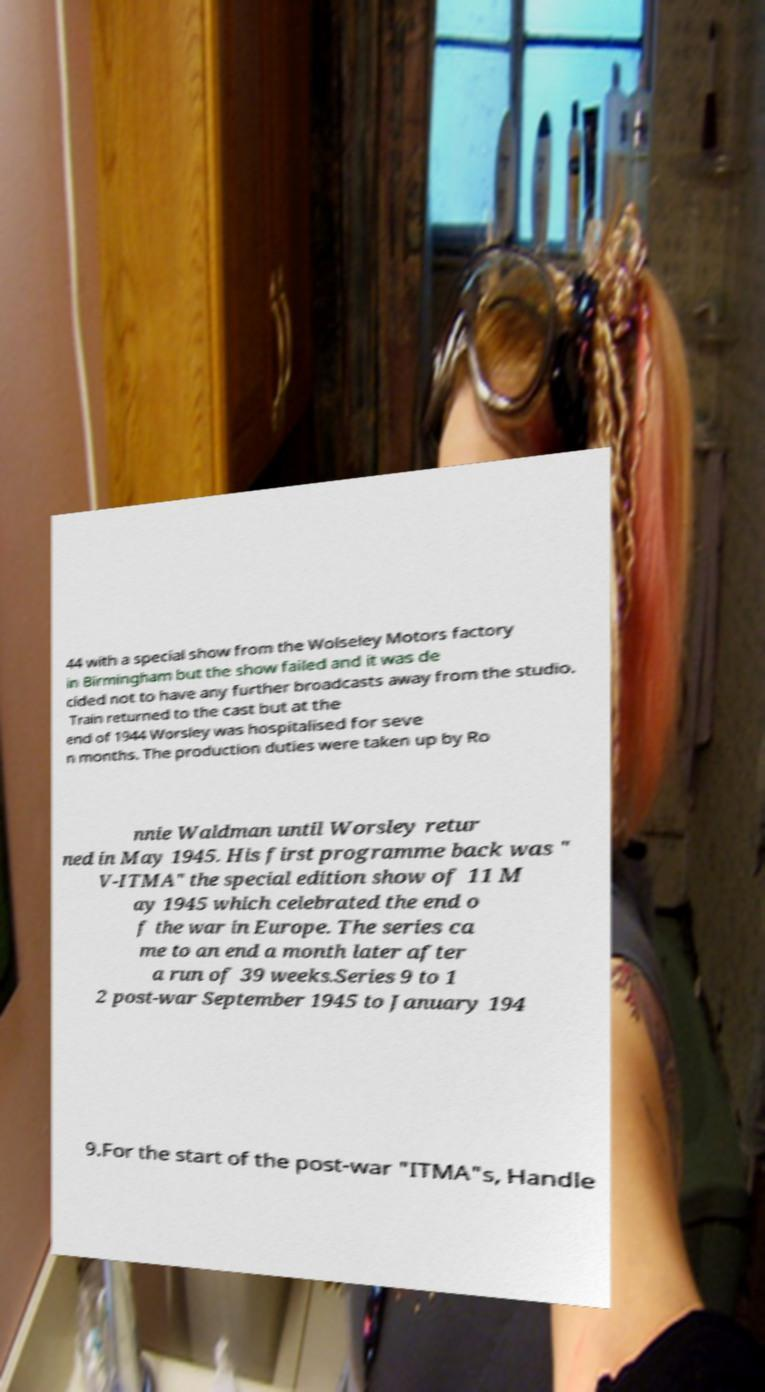Could you extract and type out the text from this image? 44 with a special show from the Wolseley Motors factory in Birmingham but the show failed and it was de cided not to have any further broadcasts away from the studio. Train returned to the cast but at the end of 1944 Worsley was hospitalised for seve n months. The production duties were taken up by Ro nnie Waldman until Worsley retur ned in May 1945. His first programme back was " V-ITMA" the special edition show of 11 M ay 1945 which celebrated the end o f the war in Europe. The series ca me to an end a month later after a run of 39 weeks.Series 9 to 1 2 post-war September 1945 to January 194 9.For the start of the post-war "ITMA"s, Handle 